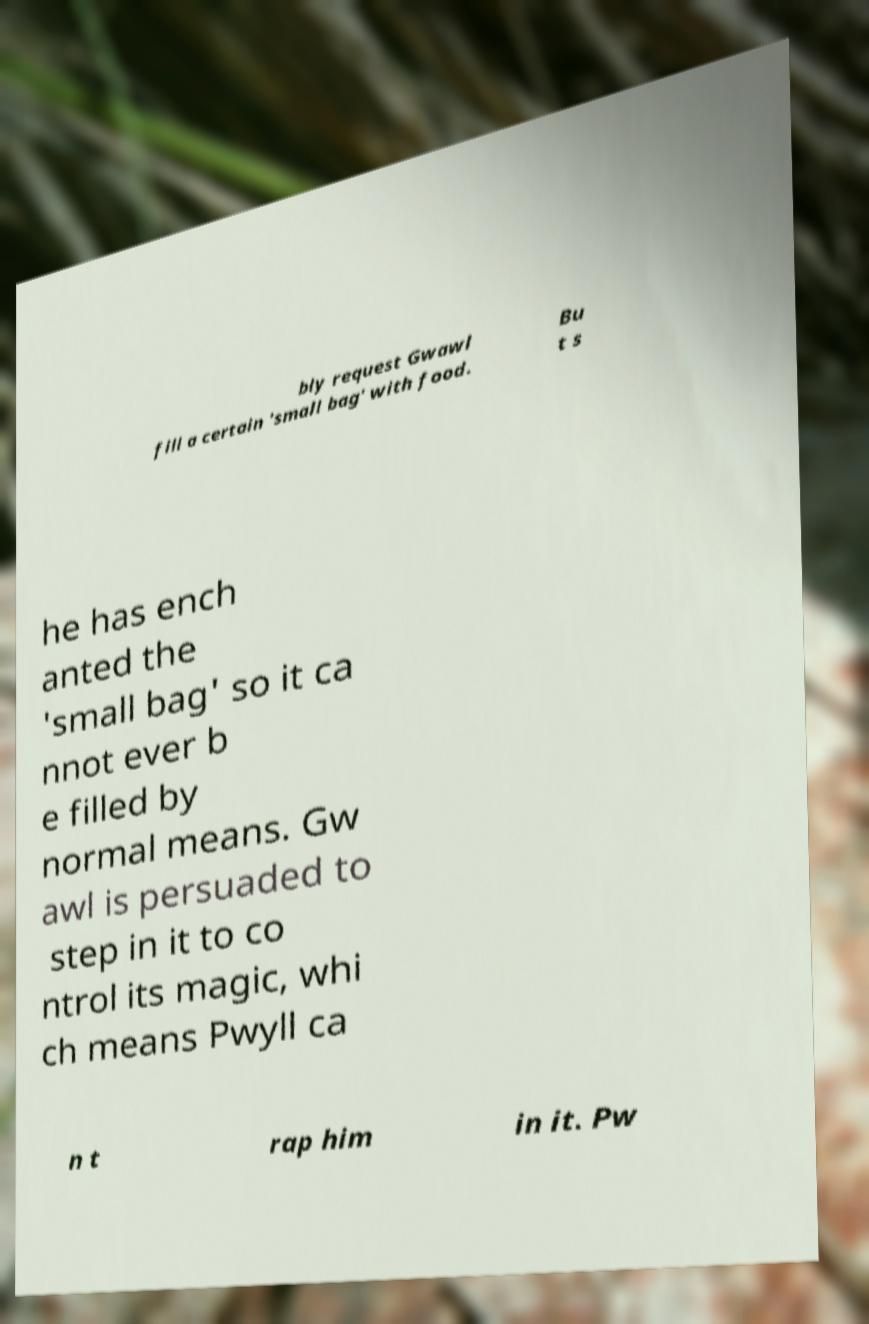I need the written content from this picture converted into text. Can you do that? bly request Gwawl fill a certain 'small bag' with food. Bu t s he has ench anted the 'small bag' so it ca nnot ever b e filled by normal means. Gw awl is persuaded to step in it to co ntrol its magic, whi ch means Pwyll ca n t rap him in it. Pw 